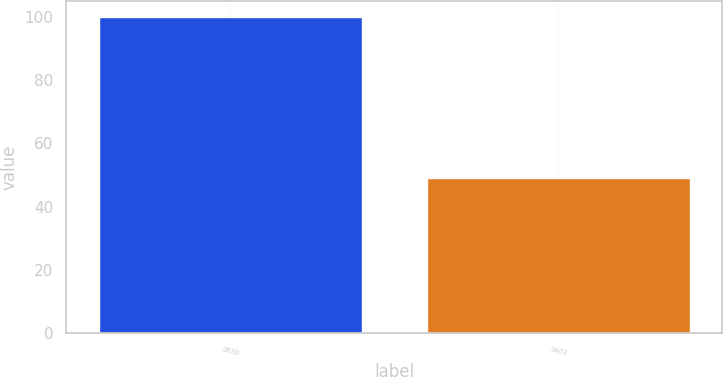<chart> <loc_0><loc_0><loc_500><loc_500><bar_chart><fcel>2630<fcel>3403<nl><fcel>100<fcel>49<nl></chart> 